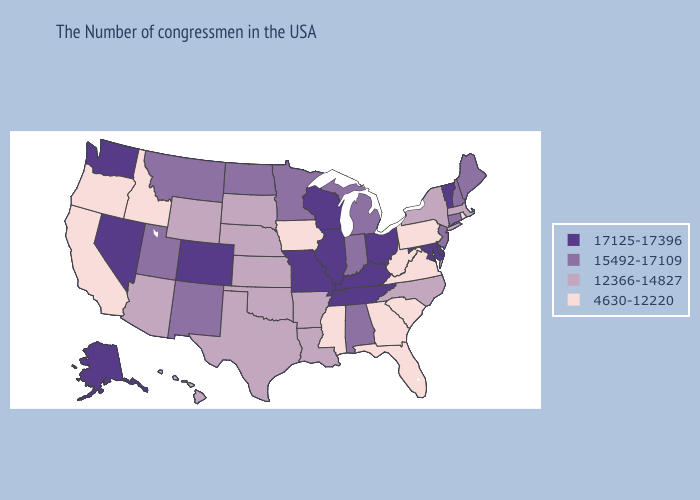Among the states that border Massachusetts , does New York have the highest value?
Answer briefly. No. Does Vermont have the highest value in the Northeast?
Quick response, please. Yes. What is the highest value in states that border Michigan?
Be succinct. 17125-17396. Name the states that have a value in the range 15492-17109?
Be succinct. Maine, New Hampshire, Connecticut, New Jersey, Michigan, Indiana, Alabama, Minnesota, North Dakota, New Mexico, Utah, Montana. What is the lowest value in the South?
Keep it brief. 4630-12220. What is the highest value in the South ?
Give a very brief answer. 17125-17396. Among the states that border Illinois , which have the highest value?
Keep it brief. Kentucky, Wisconsin, Missouri. Does Wisconsin have the highest value in the USA?
Write a very short answer. Yes. Among the states that border Delaware , does Pennsylvania have the lowest value?
Quick response, please. Yes. Does Illinois have a higher value than Tennessee?
Concise answer only. No. Does Michigan have the same value as Virginia?
Short answer required. No. What is the highest value in the West ?
Short answer required. 17125-17396. Does Colorado have a higher value than New York?
Write a very short answer. Yes. What is the value of Idaho?
Write a very short answer. 4630-12220. Does the map have missing data?
Quick response, please. No. 